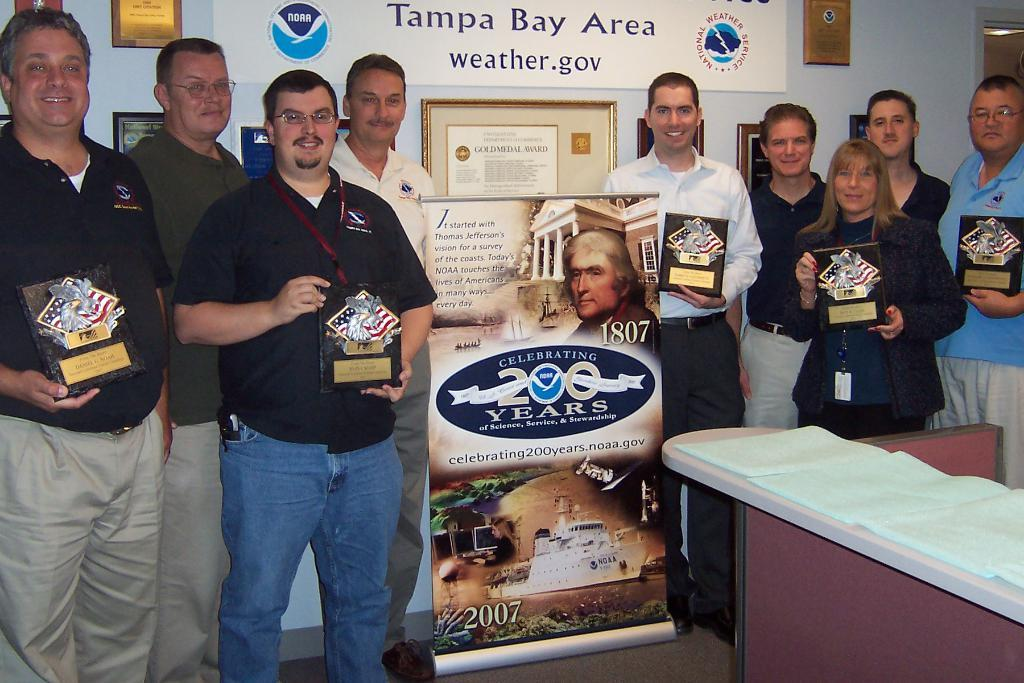<image>
Offer a succinct explanation of the picture presented. A group of people holding trophies under a poster that says Tampa Bay Area. 